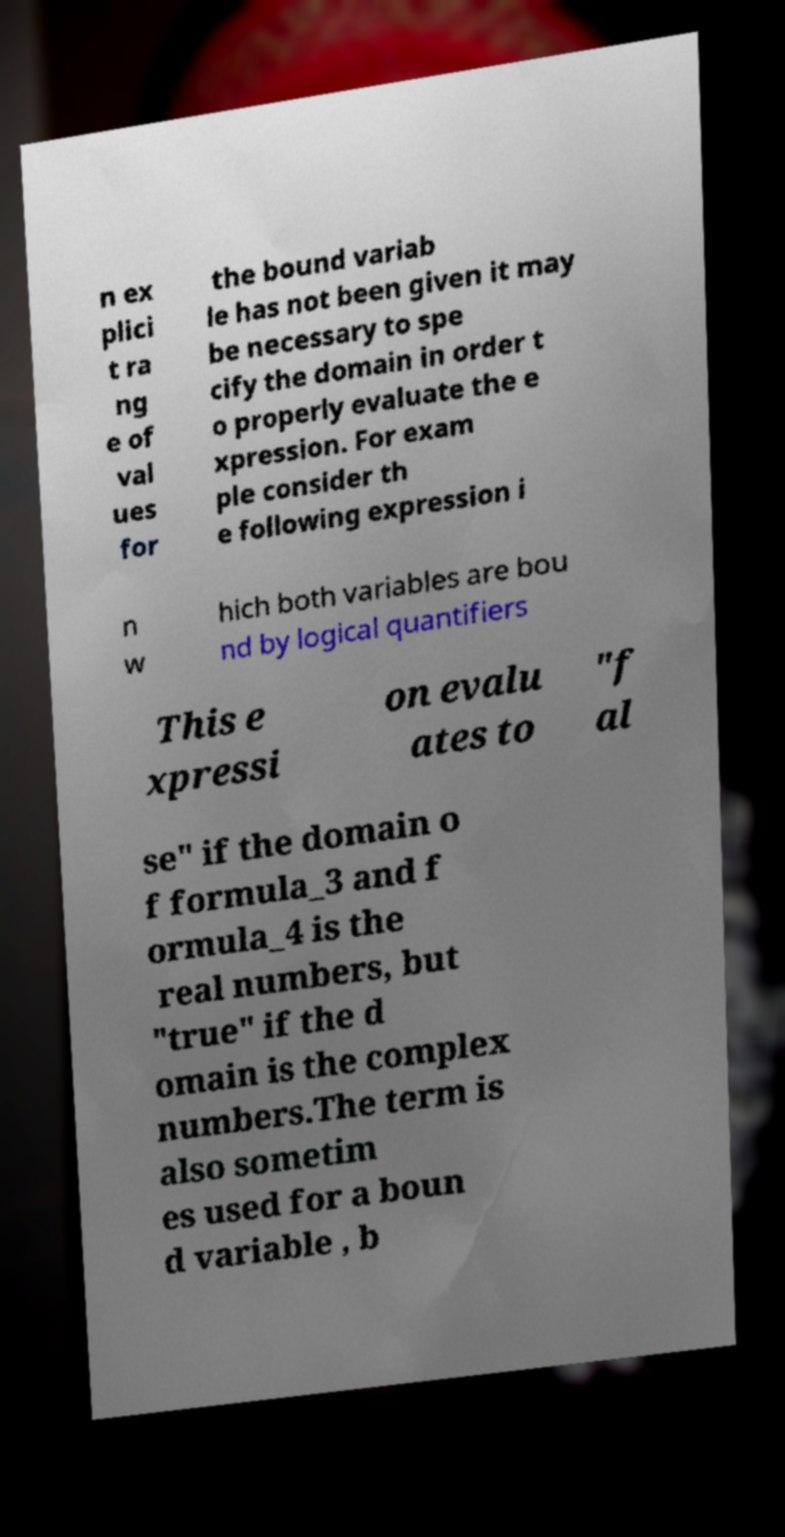Can you read and provide the text displayed in the image?This photo seems to have some interesting text. Can you extract and type it out for me? n ex plici t ra ng e of val ues for the bound variab le has not been given it may be necessary to spe cify the domain in order t o properly evaluate the e xpression. For exam ple consider th e following expression i n w hich both variables are bou nd by logical quantifiers This e xpressi on evalu ates to "f al se" if the domain o f formula_3 and f ormula_4 is the real numbers, but "true" if the d omain is the complex numbers.The term is also sometim es used for a boun d variable , b 